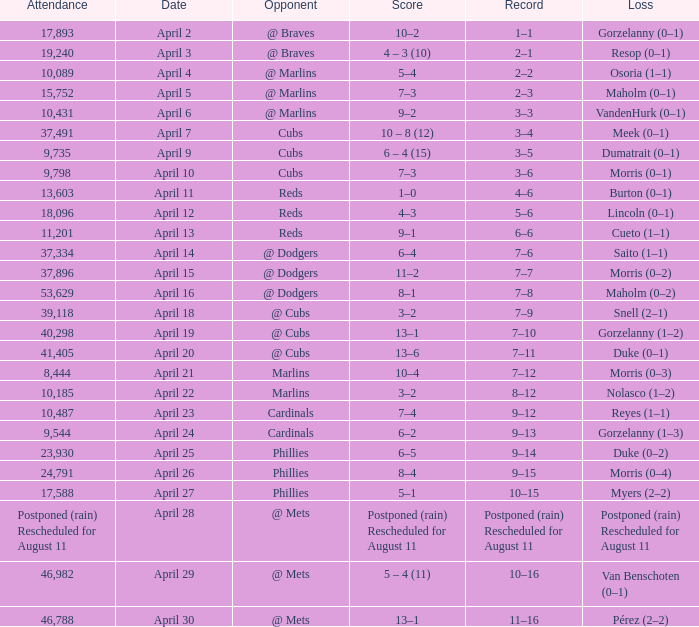What opponent had an attendance of 10,089? @ Marlins. 